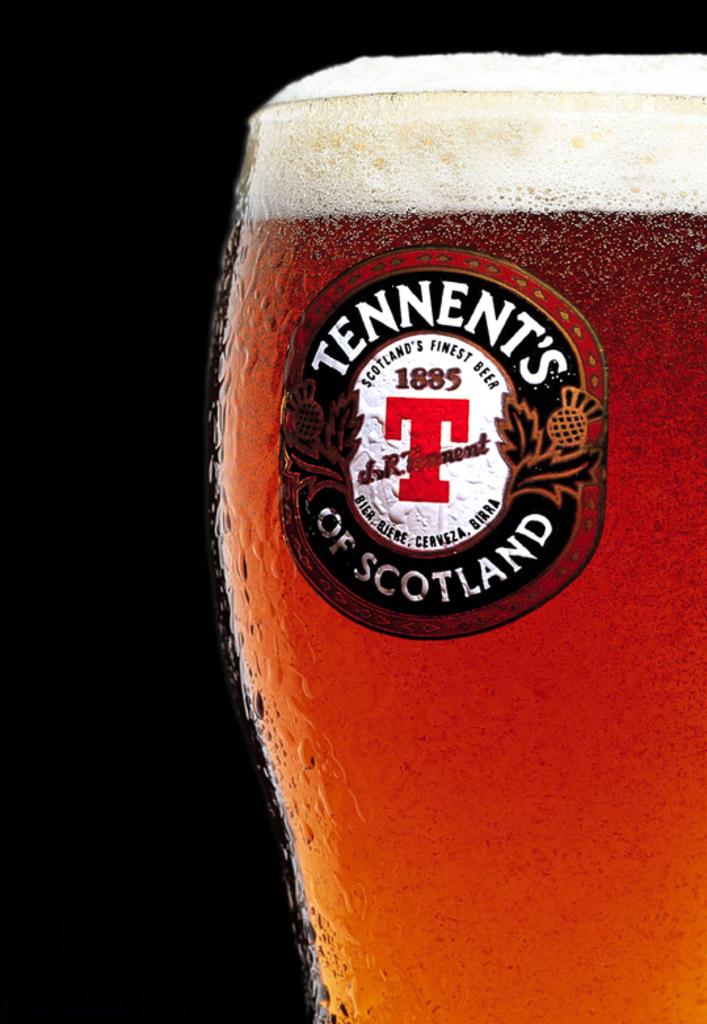Who made this beer?
Your answer should be compact. Tennent's. 